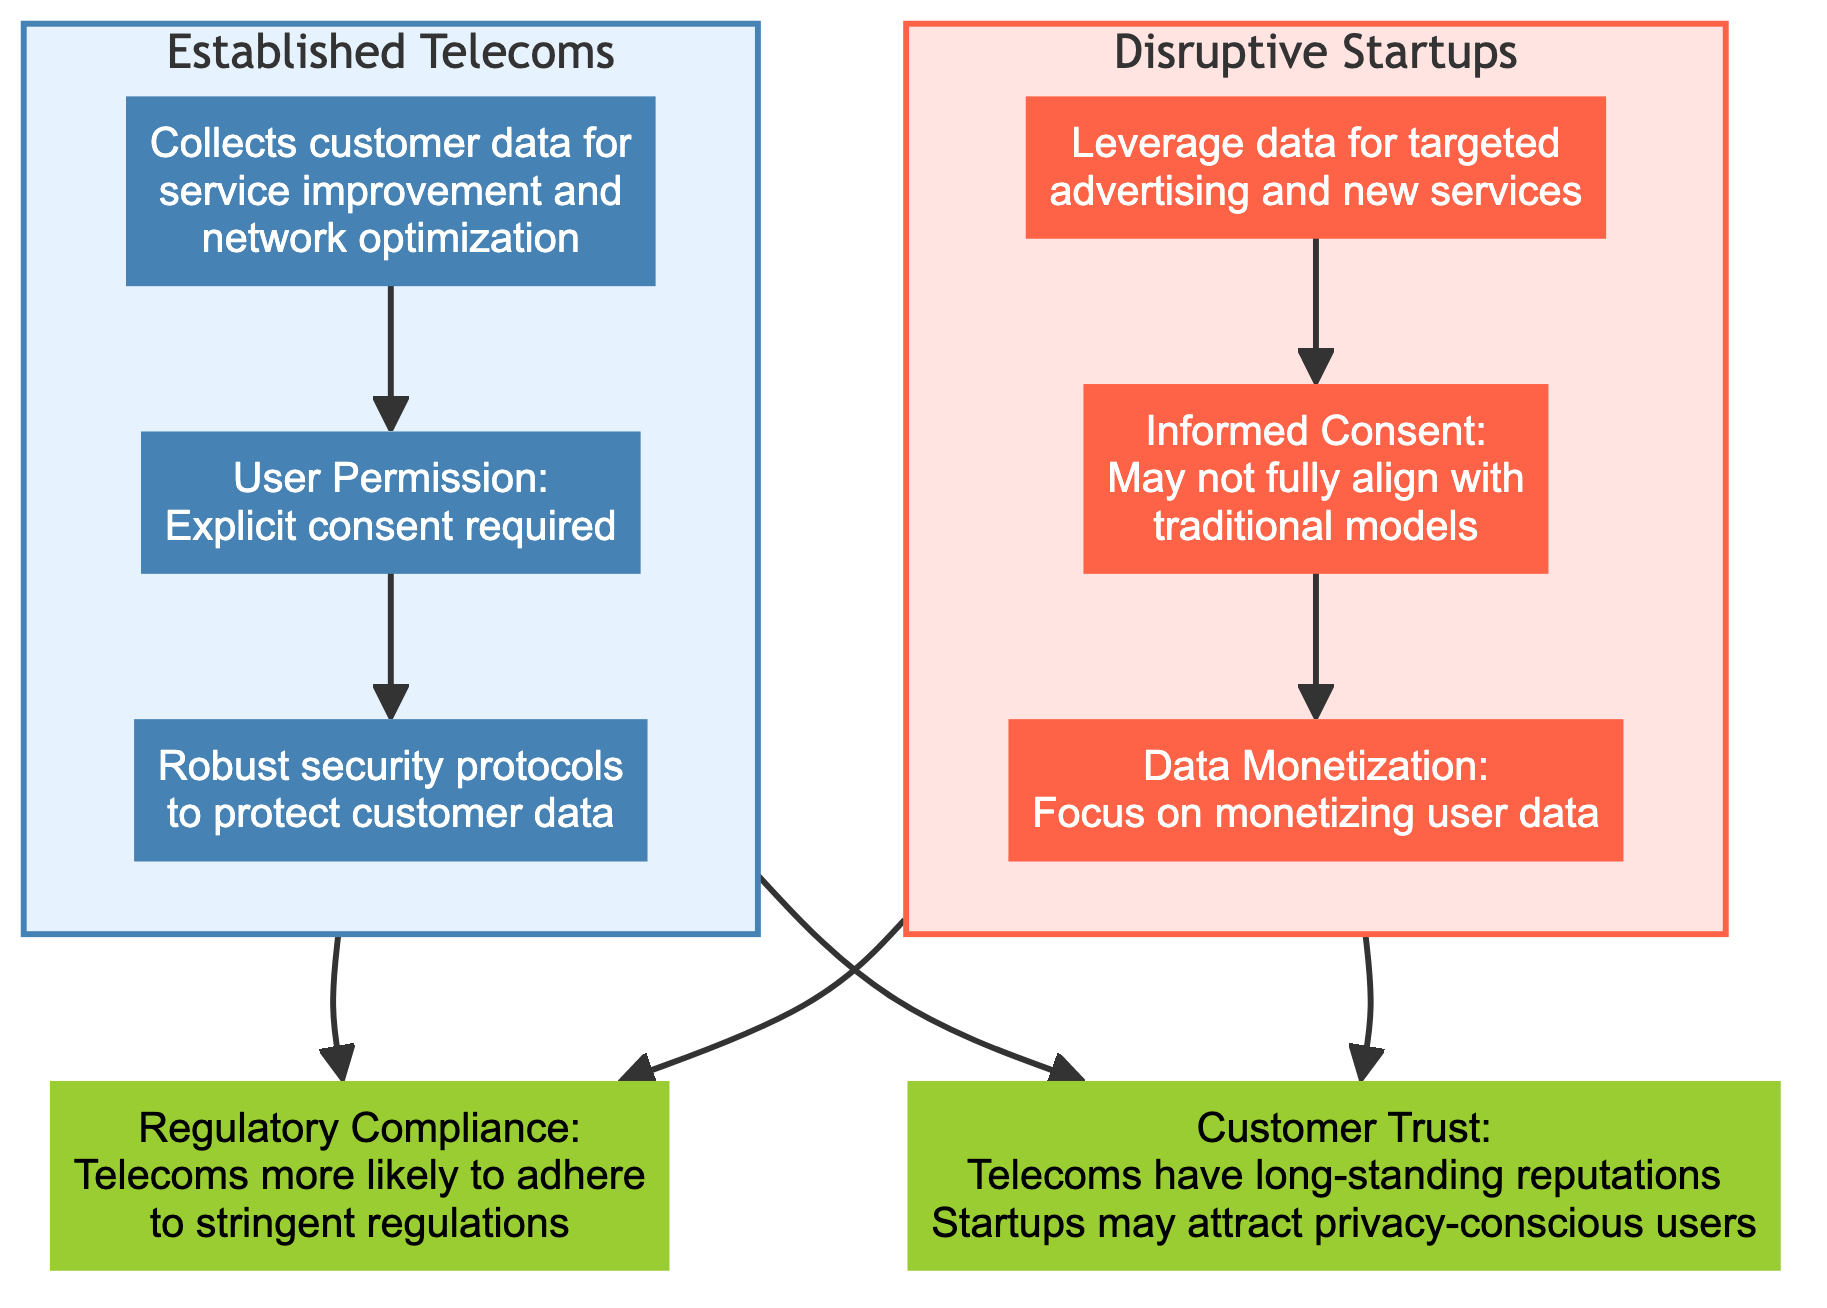What do established telecoms collect customer data for? The diagram states that established telecoms collect customer data for service improvement and network optimization. This is the specific description indicated under the "Established Telecoms" subgraph.
Answer: Service improvement and network optimization What type of consent do established telecoms require for data collection? The diagram specifies that established telecoms require explicit consent for data collection as indicated in the User Permission node.
Answer: Explicit consent What security measures do established telecoms employ? According to the diagram, the established telecoms implement robust security protocols to protect customer data, which is illustrated under the Data Security Measures node.
Answer: Robust security protocols What is the main focus of disruptive startups in terms of data? The diagram indicates that disruptive startups focus on monetizing user data, as shown in the Data Monetization Strategies node.
Answer: Monetizing user data How do regulatory compliance levels compare between established telecoms and startups? The diagram illustrates that established telecoms are more likely to adhere to stringent regulations, while startups might overlook these frameworks for rapid growth, as presented in the Regulatory Compliance node.
Answer: Established telecoms adhere more How does customer trust differ between established telecoms and startups? The diagram mentions that established telecoms have long-standing reputations but also face privacy concerns, whereas startups may attract privacy-conscious users despite their business models. This comparison is captured in the Customer Trust node.
Answer: Established telecoms have long-standing reputations What kind of consent practices do disruptive startups utilize? The diagram describes that disruptive startups may not fully align with traditional consent models under privacy laws, which is noted in the Informed Consent Practices node.
Answer: Not fully align with traditional models Which entity is mentioned to possibly risk privacy infringement through their data strategies? The diagram indicates that disruptive startups, due to their focus on monetizing user data, could potentially risk privacy infringement. This is described in the Data Monetization Strategies node.
Answer: Disruptive startups How many subgraphs are present in the diagram? There are two subgraphs in the diagram: one for Established Telecoms and another for Disruptive Startups. The presence of two distinct sections confirms this count.
Answer: Two subgraphs What type of data collection practices might startups overlook for rapid growth? The diagram suggests that startups might overlook regulatory frameworks regarding data collection practices, specifically for compliance with laws as indicated in the Regulatory Compliance node.
Answer: Regulatory frameworks 